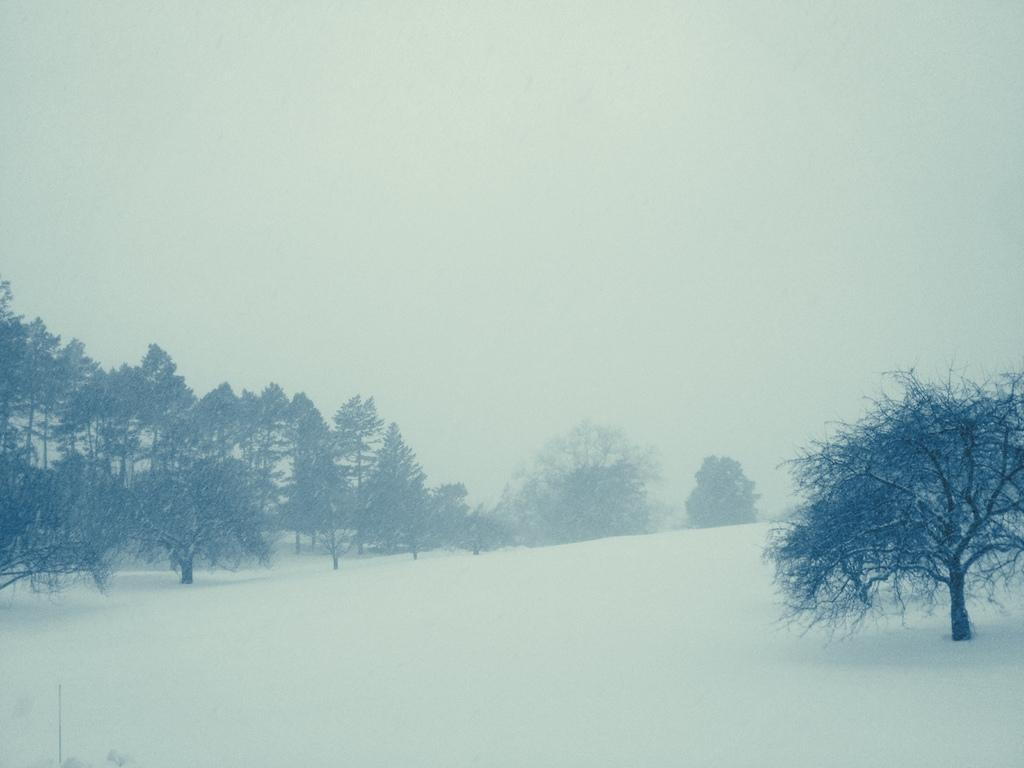What is the main feature in the middle of the image? There is snow in the middle of the image. What can be seen on the left side of the image? There are trees on the left side of the image. What is visible at the top of the image? The sky is visible at the top of the image. How does the maid balance the scissors on the snow in the image? There is no maid or scissors present in the image; it features snow and trees. 